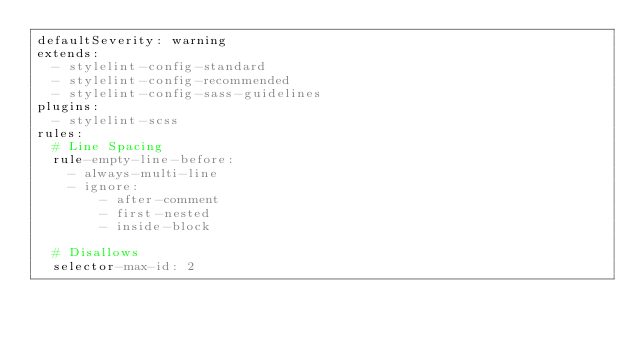Convert code to text. <code><loc_0><loc_0><loc_500><loc_500><_YAML_>defaultSeverity: warning
extends:
  - stylelint-config-standard
  - stylelint-config-recommended
  - stylelint-config-sass-guidelines
plugins:
  - stylelint-scss
rules:
  # Line Spacing
  rule-empty-line-before:
    - always-multi-line
    - ignore:
        - after-comment
        - first-nested
        - inside-block

  # Disallows
  selector-max-id: 2</code> 